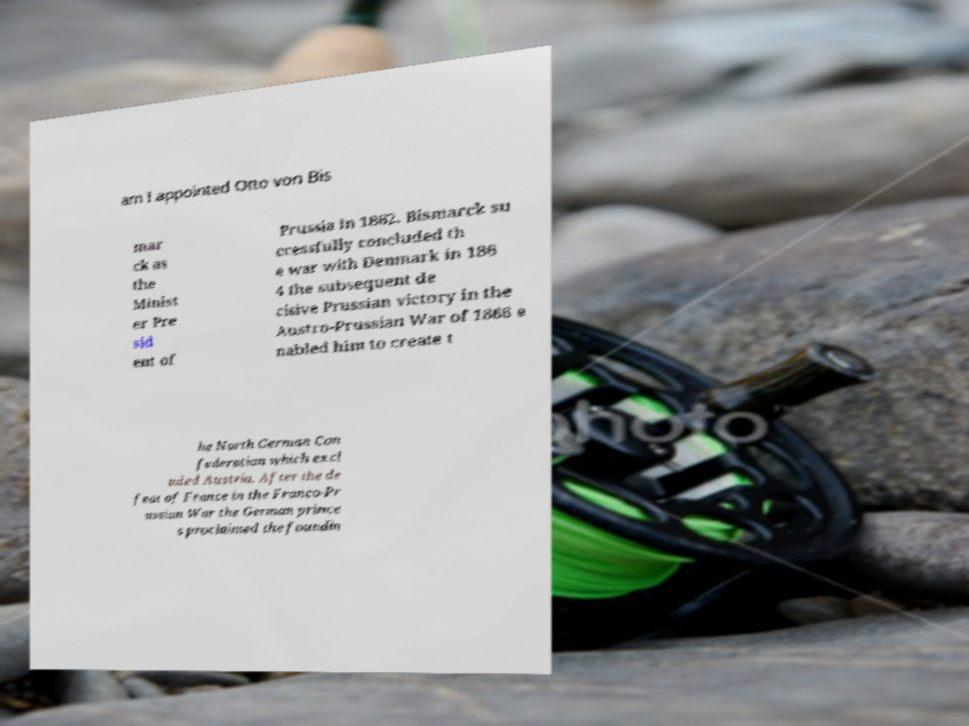Can you read and provide the text displayed in the image?This photo seems to have some interesting text. Can you extract and type it out for me? am I appointed Otto von Bis mar ck as the Minist er Pre sid ent of Prussia in 1862. Bismarck su ccessfully concluded th e war with Denmark in 186 4 the subsequent de cisive Prussian victory in the Austro-Prussian War of 1866 e nabled him to create t he North German Con federation which excl uded Austria. After the de feat of France in the Franco-Pr ussian War the German prince s proclaimed the foundin 